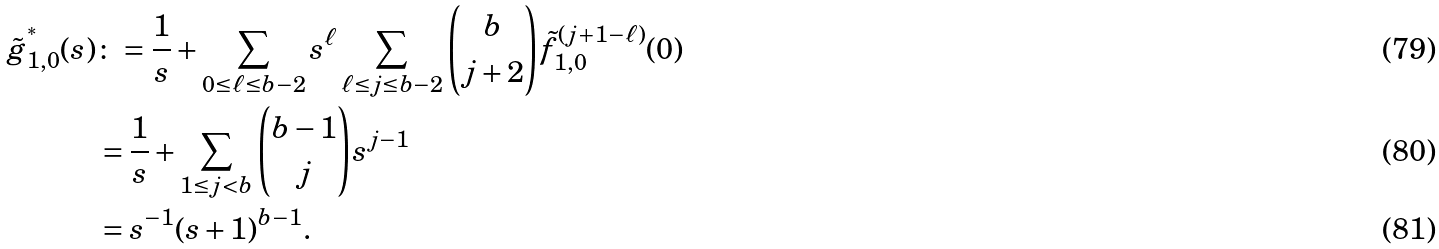Convert formula to latex. <formula><loc_0><loc_0><loc_500><loc_500>\tilde { g } _ { 1 , 0 } ^ { ^ { * } } ( s ) & \colon = \frac { 1 } { s } + \sum _ { 0 \leq \ell \leq b - 2 } s ^ { \ell } \sum _ { \ell \leq j \leq b - 2 } \binom { b } { j + 2 } \tilde { f } ^ { ( j + 1 - \ell ) } _ { 1 , 0 } ( 0 ) \\ & = \frac { 1 } { s } + \sum _ { 1 \leq j < b } \binom { b - 1 } j s ^ { j - 1 } \\ & = s ^ { - 1 } ( s + 1 ) ^ { b - 1 } .</formula> 